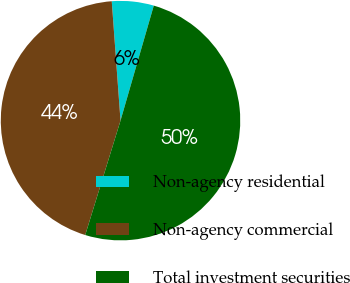Convert chart to OTSL. <chart><loc_0><loc_0><loc_500><loc_500><pie_chart><fcel>Non-agency residential<fcel>Non-agency commercial<fcel>Total investment securities<nl><fcel>5.65%<fcel>44.07%<fcel>50.28%<nl></chart> 